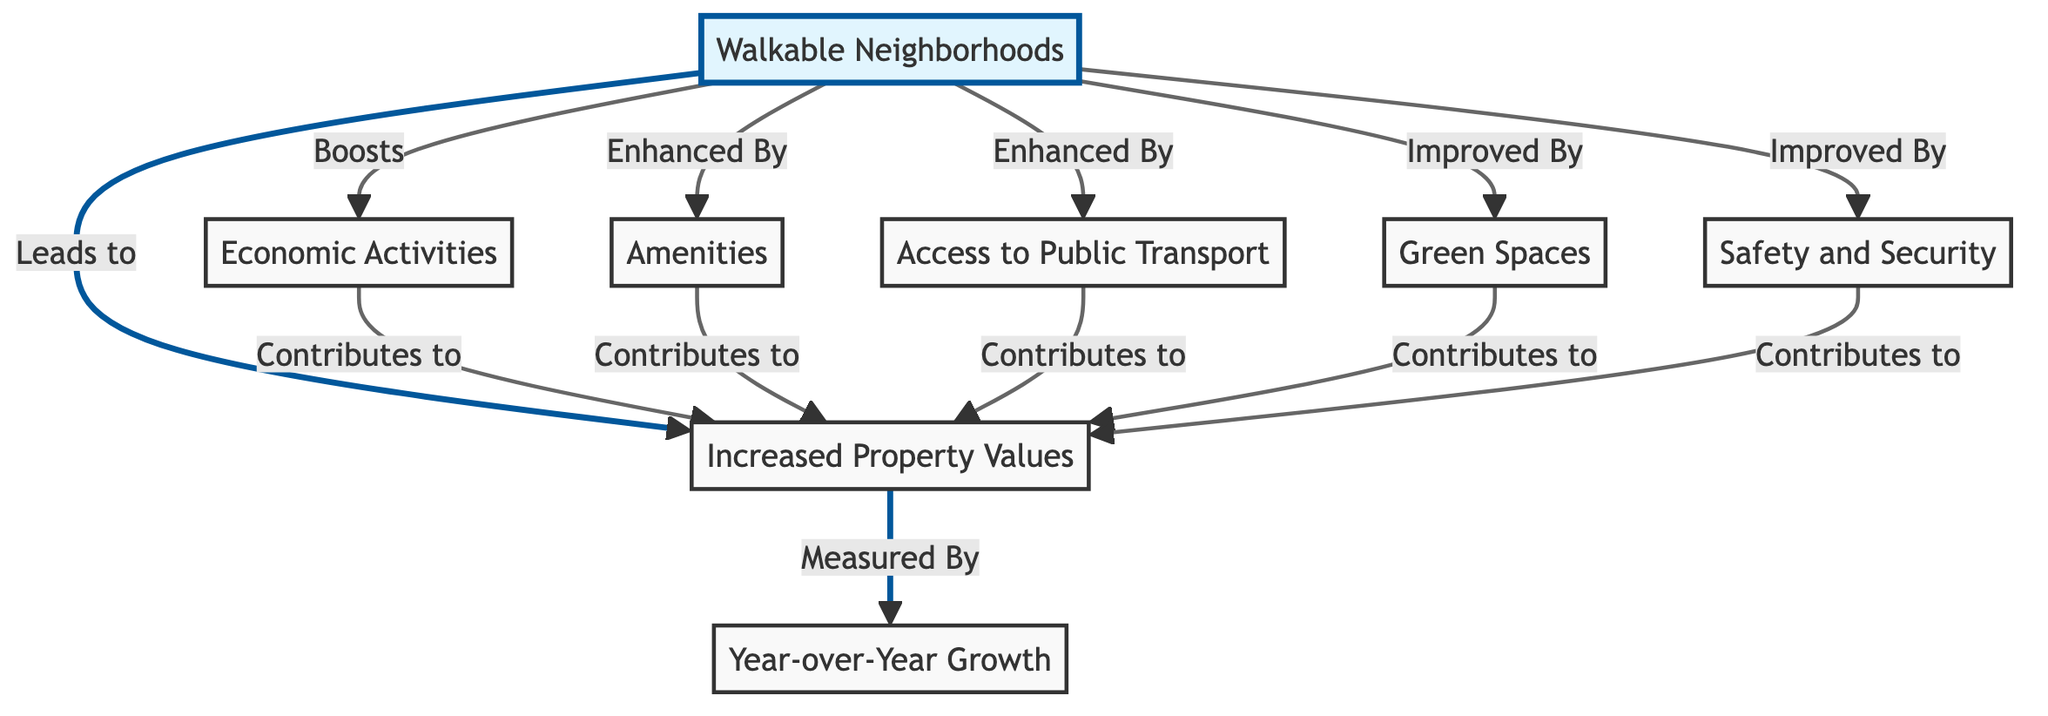What is the starting point of the diagram? The diagram begins with the node labeled 'Walkable Neighborhoods', which represents the foundation for the concepts that follow.
Answer: Walkable Neighborhoods How many nodes contribute to increased property values? There are five nodes that directly contribute to increased property values: Amenities, Access to Public Transport, Economic Activities, Green Spaces, and Safety and Security.
Answer: Five What aspect is measured by 'Year-over-Year Growth'? 'Increased Property Values' is quantified by 'Year-over-Year Growth', which indicates how property values have changed over time.
Answer: Increased Property Values Which node enhances walkable neighborhoods through public transport? The node labeled 'Access to Public Transport' enhances walkable neighborhoods by making them more accessible and desirable.
Answer: Access to Public Transport How does Economic Activities relate to property values? 'Economic Activities' boosts property values, indicating a direct correlation between vibrant economic conditions and property market performance.
Answer: Boosts Which two factors together contribute to increased property values? Both 'Green Spaces' and 'Safety and Security' contribute significantly to increased property values, emphasizing the importance of environmental and social elements.
Answer: Green Spaces and Safety and Security What is the relationship between amenities and property values? The 'Amenities' node is explicitly stated to enhance walkable neighborhoods, which in turn contributes to increased property values.
Answer: Enhances Which factor has a direct connection with safety in contributing to property value? 'Safety and Security' has a direct connection, contributing to the overarching goal of increased property values in walkable neighborhoods.
Answer: Safety and Security What type of diagram is this? This is a Textbook Diagram that visually represents the relationships and flow of concepts related to walkable neighborhoods and their economic impact.
Answer: Textbook Diagram 